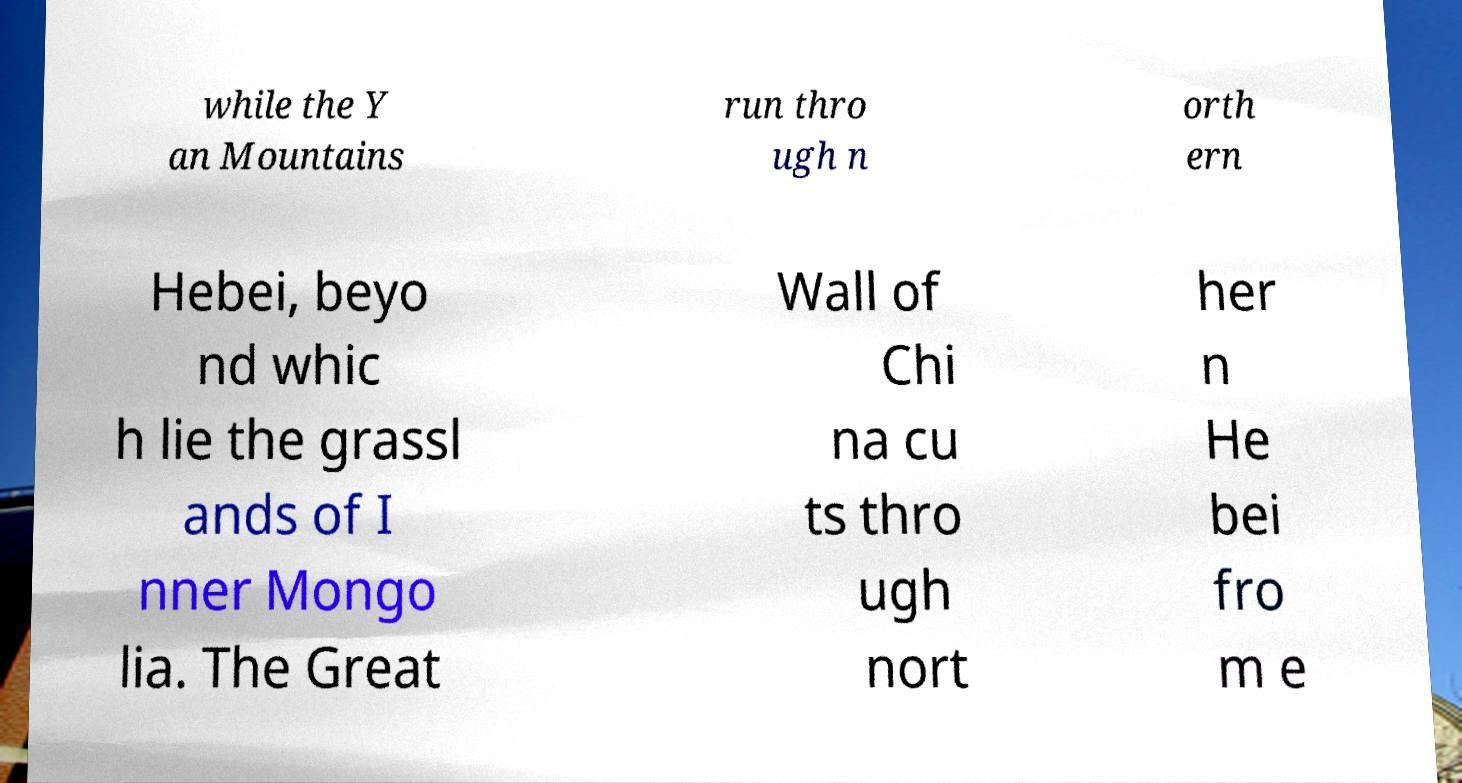I need the written content from this picture converted into text. Can you do that? while the Y an Mountains run thro ugh n orth ern Hebei, beyo nd whic h lie the grassl ands of I nner Mongo lia. The Great Wall of Chi na cu ts thro ugh nort her n He bei fro m e 